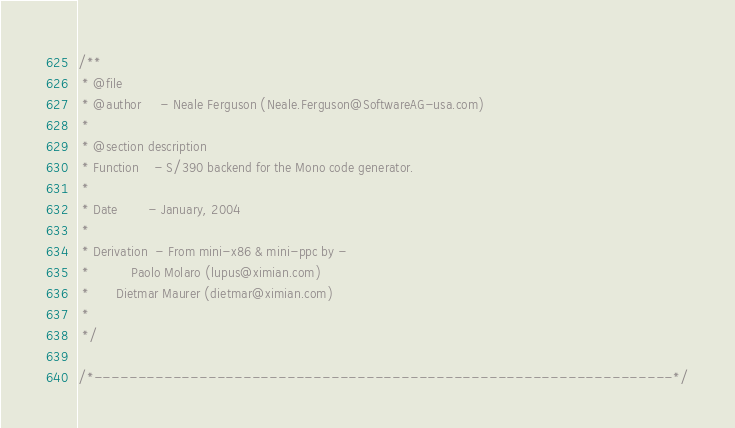Convert code to text. <code><loc_0><loc_0><loc_500><loc_500><_C_>/**
 * @file
 * @author     - Neale Ferguson (Neale.Ferguson@SoftwareAG-usa.com)
 *
 * @section description
 * Function    - S/390 backend for the Mono code generator.
 *
 * Date        - January, 2004
 *
 * Derivation  - From mini-x86 & mini-ppc by -
 * 	         Paolo Molaro (lupus@ximian.com)
 * 		 Dietmar Maurer (dietmar@ximian.com)
 *
 */

/*------------------------------------------------------------------*/</code> 